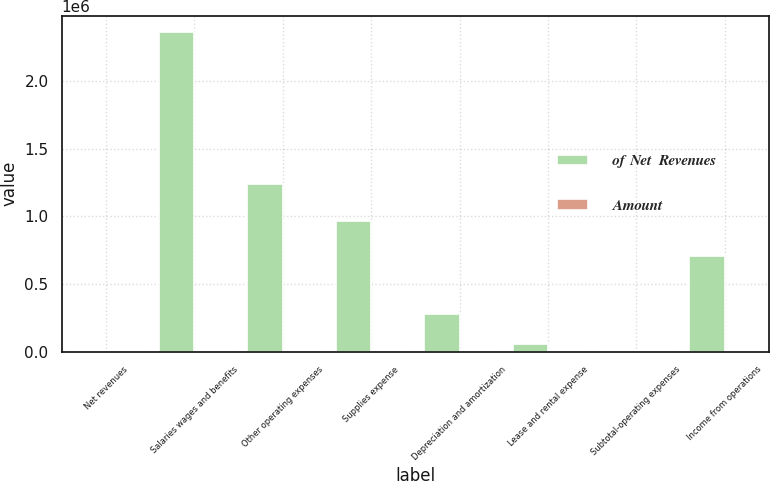<chart> <loc_0><loc_0><loc_500><loc_500><stacked_bar_chart><ecel><fcel>Net revenues<fcel>Salaries wages and benefits<fcel>Other operating expenses<fcel>Supplies expense<fcel>Depreciation and amortization<fcel>Lease and rental expense<fcel>Subtotal-operating expenses<fcel>Income from operations<nl><fcel>of Net  Revenues<fcel>93.7<fcel>2.36608e+06<fcel>1.23879e+06<fcel>967833<fcel>278558<fcel>57229<fcel>93.7<fcel>709943<nl><fcel>Amount<fcel>100<fcel>42.1<fcel>22<fcel>17.2<fcel>5<fcel>1<fcel>87.4<fcel>12.6<nl></chart> 